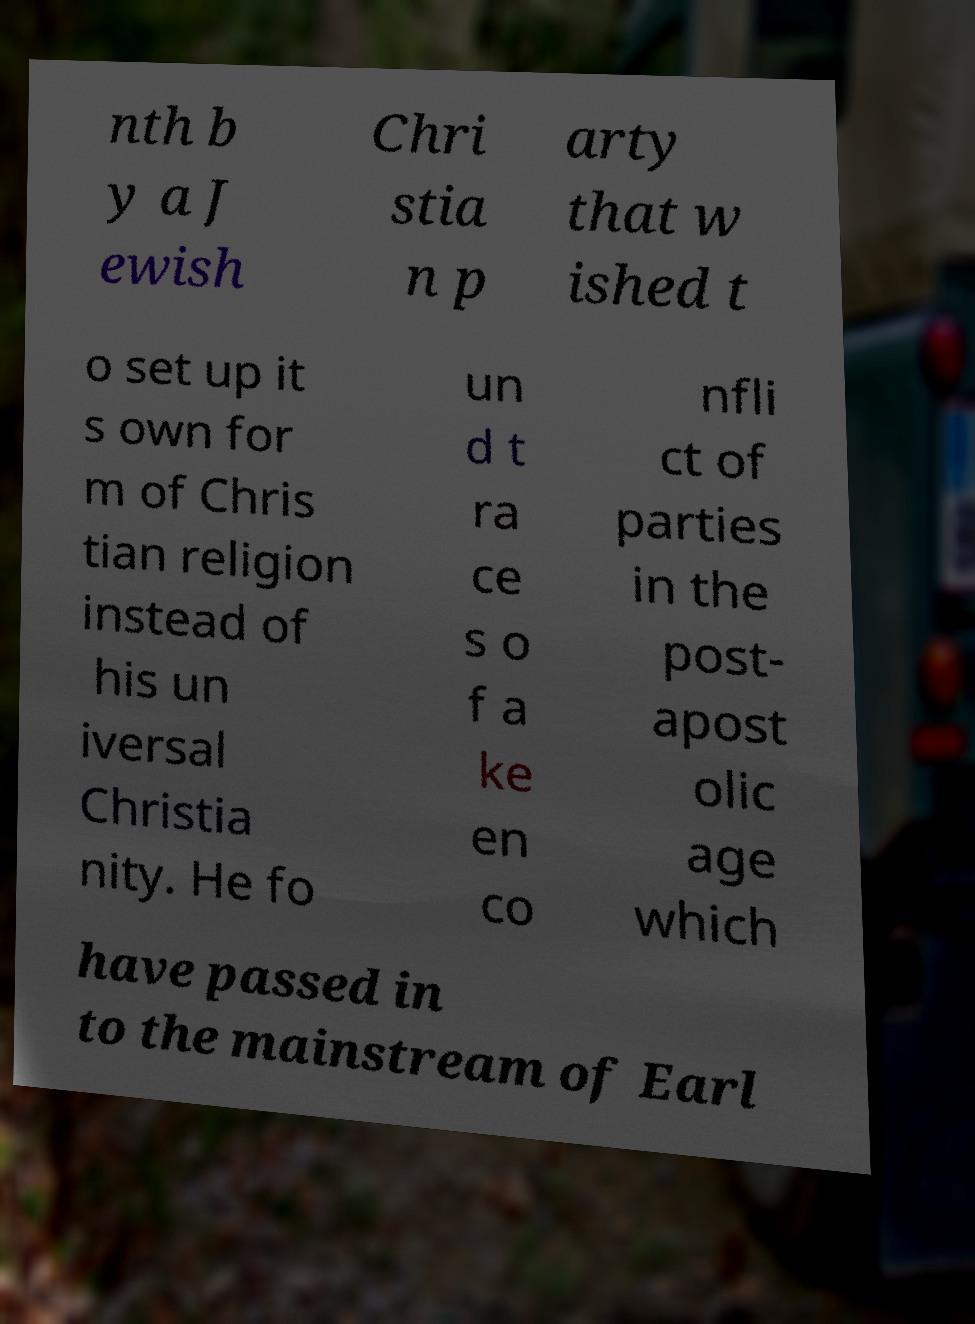There's text embedded in this image that I need extracted. Can you transcribe it verbatim? nth b y a J ewish Chri stia n p arty that w ished t o set up it s own for m of Chris tian religion instead of his un iversal Christia nity. He fo un d t ra ce s o f a ke en co nfli ct of parties in the post- apost olic age which have passed in to the mainstream of Earl 